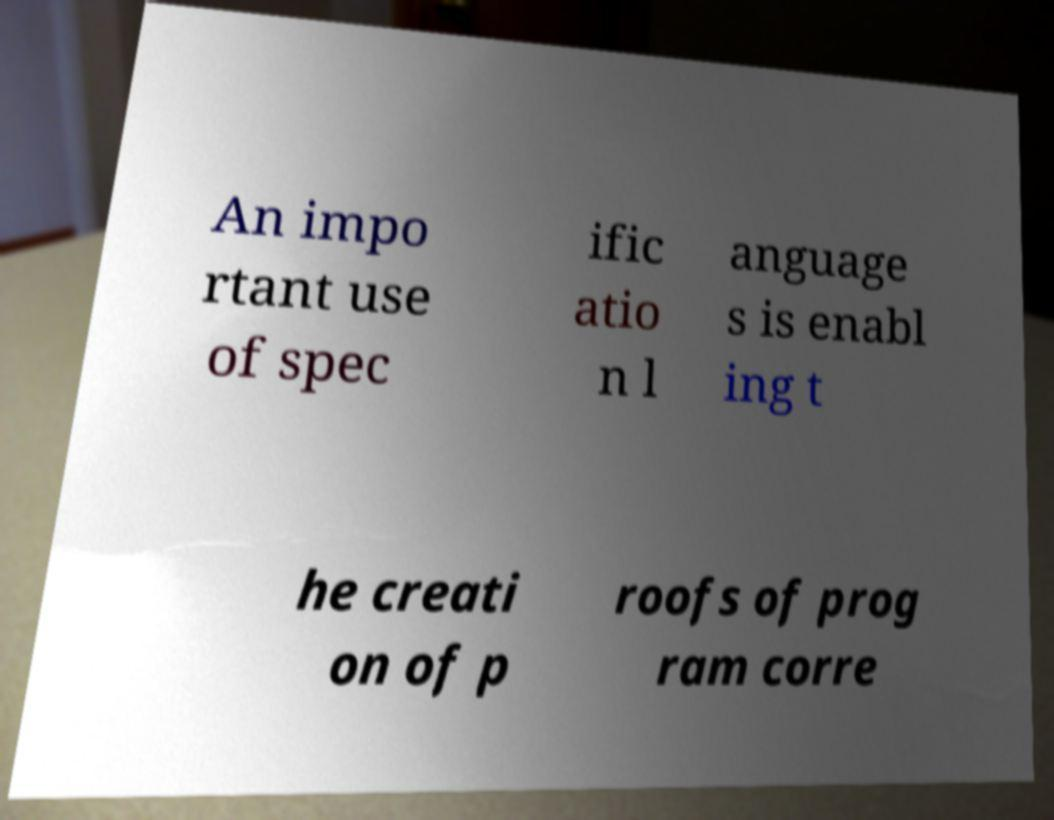Could you extract and type out the text from this image? An impo rtant use of spec ific atio n l anguage s is enabl ing t he creati on of p roofs of prog ram corre 